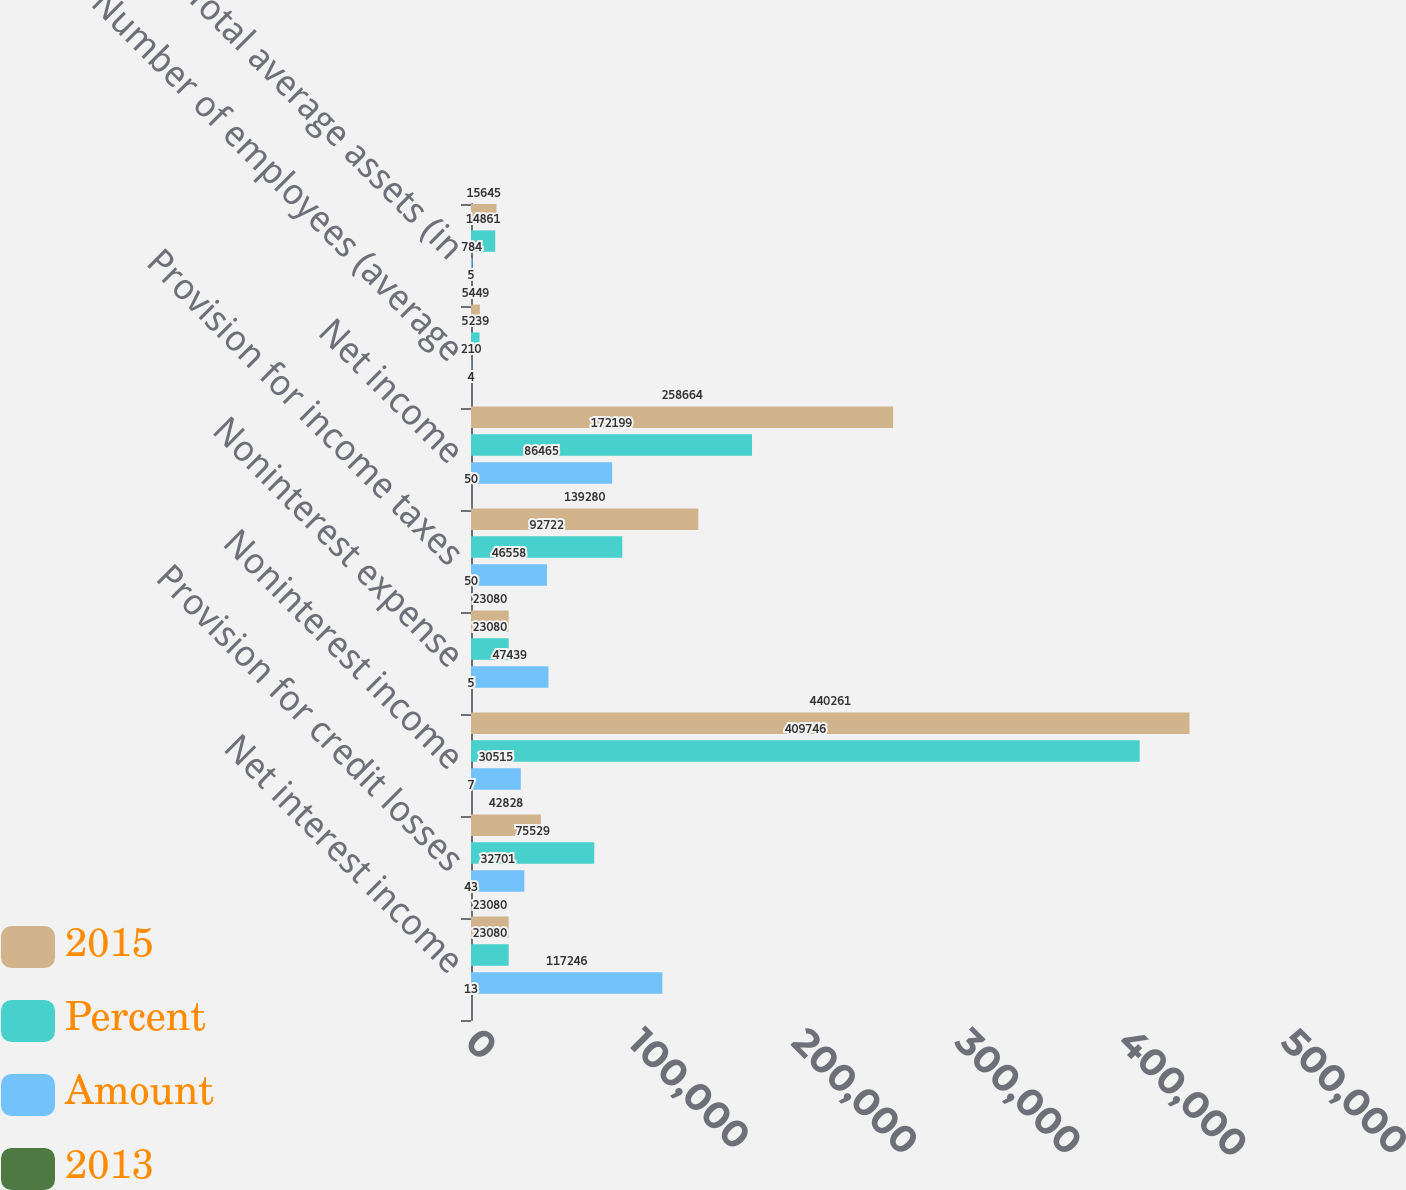<chart> <loc_0><loc_0><loc_500><loc_500><stacked_bar_chart><ecel><fcel>Net interest income<fcel>Provision for credit losses<fcel>Noninterest income<fcel>Noninterest expense<fcel>Provision for income taxes<fcel>Net income<fcel>Number of employees (average<fcel>Total average assets (in<nl><fcel>2015<fcel>23080<fcel>42828<fcel>440261<fcel>23080<fcel>139280<fcel>258664<fcel>5449<fcel>15645<nl><fcel>Percent<fcel>23080<fcel>75529<fcel>409746<fcel>23080<fcel>92722<fcel>172199<fcel>5239<fcel>14861<nl><fcel>Amount<fcel>117246<fcel>32701<fcel>30515<fcel>47439<fcel>46558<fcel>86465<fcel>210<fcel>784<nl><fcel>2013<fcel>13<fcel>43<fcel>7<fcel>5<fcel>50<fcel>50<fcel>4<fcel>5<nl></chart> 